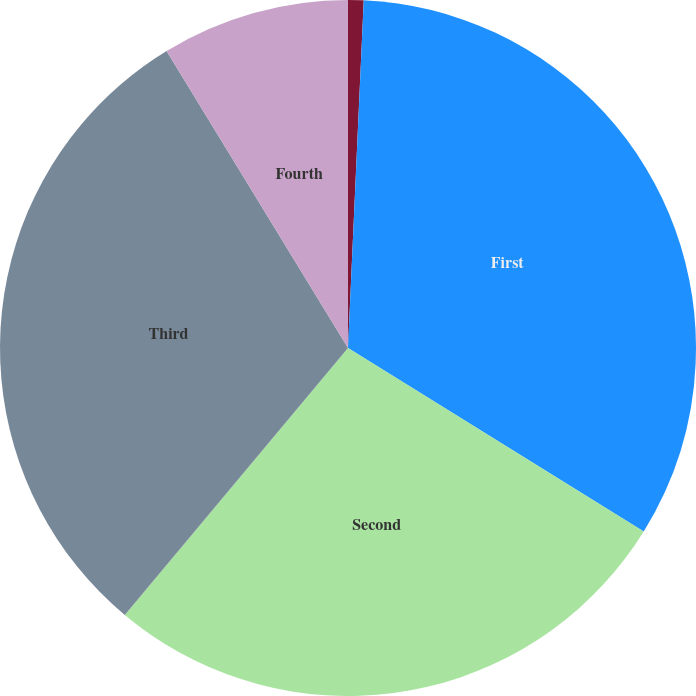Convert chart. <chart><loc_0><loc_0><loc_500><loc_500><pie_chart><fcel>Quarter<fcel>First<fcel>Second<fcel>Third<fcel>Fourth<nl><fcel>0.72%<fcel>33.12%<fcel>27.25%<fcel>30.19%<fcel>8.73%<nl></chart> 